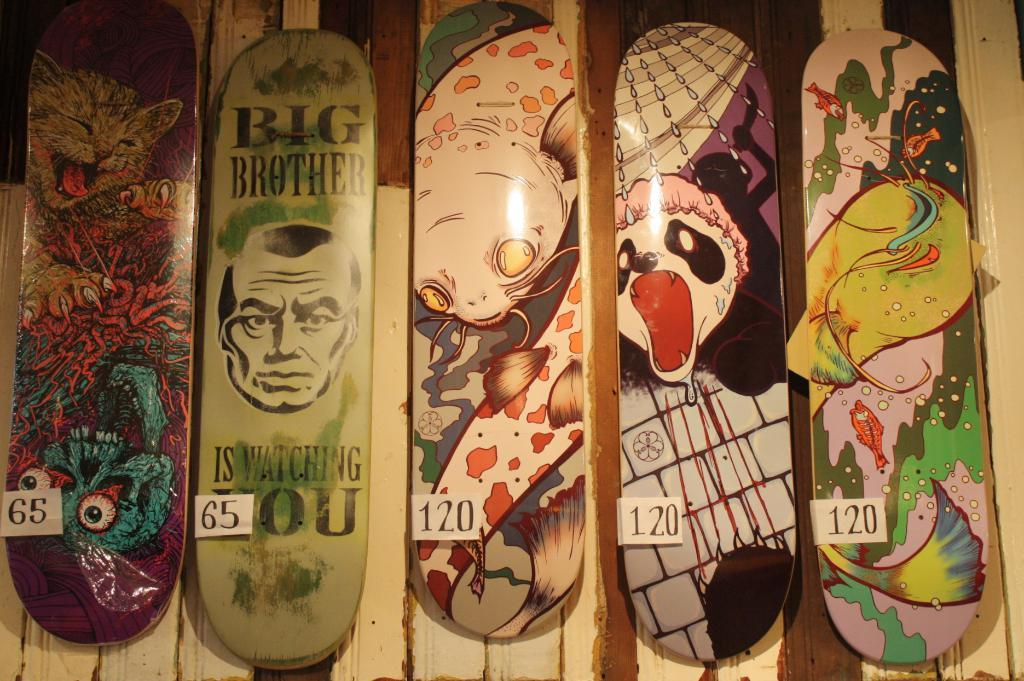What is depicted on the boards in the image? There are paintings on the boards in the image. Where are the boards with paintings located? The boards are attached to a wooden wall. What else can be seen on the boards besides the paintings? Number papers are attached to the boards. What type of cloth is draped over the boards in the image? There is no cloth draped over the boards in the image; the boards have paintings and number papers attached to them. 